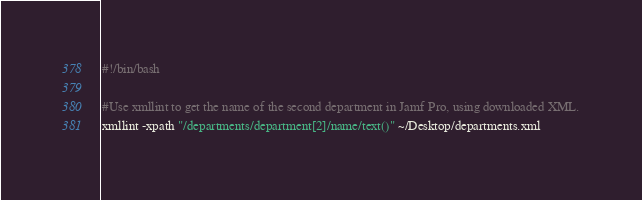<code> <loc_0><loc_0><loc_500><loc_500><_Bash_>#!/bin/bash

#Use xmllint to get the name of the second department in Jamf Pro, using downloaded XML.
xmllint -xpath "/departments/department[2]/name/text()" ~/Desktop/departments.xml</code> 